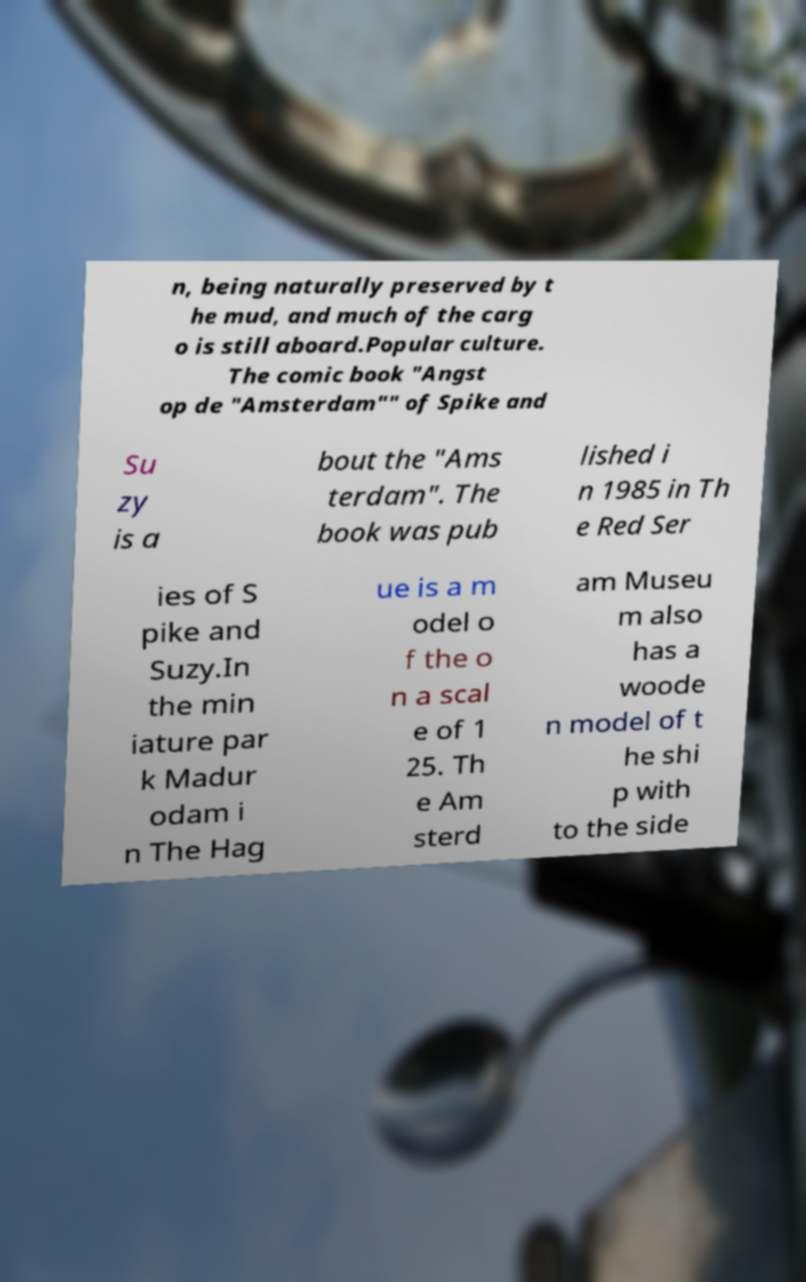For documentation purposes, I need the text within this image transcribed. Could you provide that? n, being naturally preserved by t he mud, and much of the carg o is still aboard.Popular culture. The comic book "Angst op de "Amsterdam"" of Spike and Su zy is a bout the "Ams terdam". The book was pub lished i n 1985 in Th e Red Ser ies of S pike and Suzy.In the min iature par k Madur odam i n The Hag ue is a m odel o f the o n a scal e of 1 25. Th e Am sterd am Museu m also has a woode n model of t he shi p with to the side 